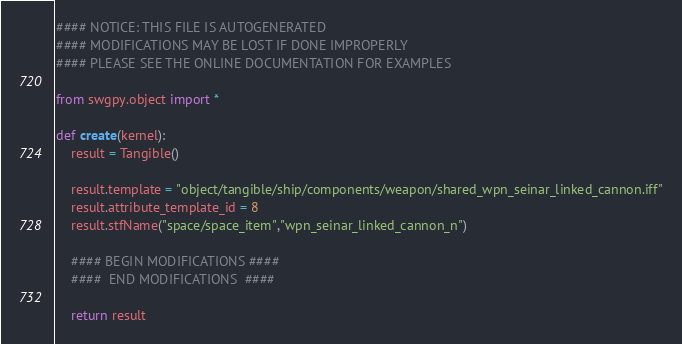<code> <loc_0><loc_0><loc_500><loc_500><_Python_>#### NOTICE: THIS FILE IS AUTOGENERATED
#### MODIFICATIONS MAY BE LOST IF DONE IMPROPERLY
#### PLEASE SEE THE ONLINE DOCUMENTATION FOR EXAMPLES

from swgpy.object import *	

def create(kernel):
	result = Tangible()

	result.template = "object/tangible/ship/components/weapon/shared_wpn_seinar_linked_cannon.iff"
	result.attribute_template_id = 8
	result.stfName("space/space_item","wpn_seinar_linked_cannon_n")		
	
	#### BEGIN MODIFICATIONS ####
	####  END MODIFICATIONS  ####
	
	return result</code> 